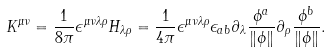Convert formula to latex. <formula><loc_0><loc_0><loc_500><loc_500>K ^ { \mu \nu } = \frac { 1 } { 8 \pi } \epsilon ^ { \mu \nu \lambda \rho } H _ { \lambda \rho } = \frac { 1 } { 4 \pi } \epsilon ^ { \mu \nu \lambda \rho } \epsilon _ { a b } \partial _ { \lambda } \frac { \phi ^ { a } } { \| \phi \| } \partial _ { \rho } \frac { \phi ^ { b } } { \| \phi \| } .</formula> 